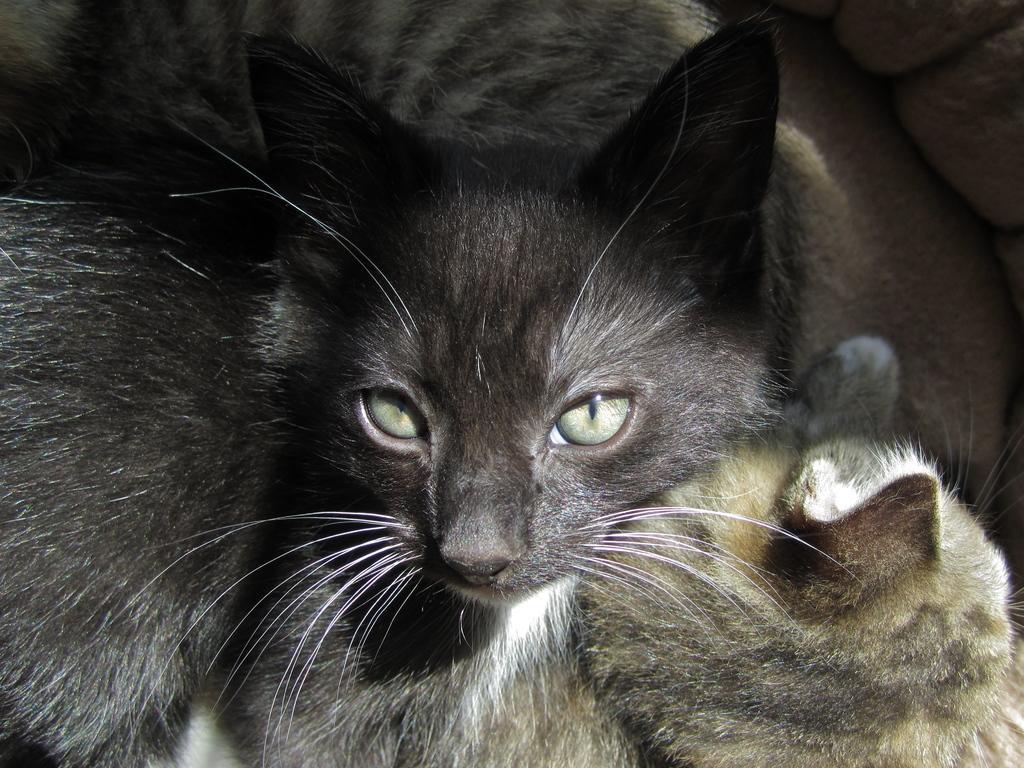In one or two sentences, can you explain what this image depicts? In the image in the center we can see two cats,which are in black,brown and white color. 